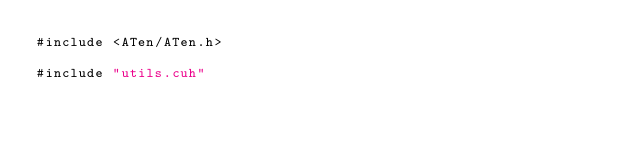<code> <loc_0><loc_0><loc_500><loc_500><_Cuda_>#include <ATen/ATen.h>

#include "utils.cuh"
</code> 